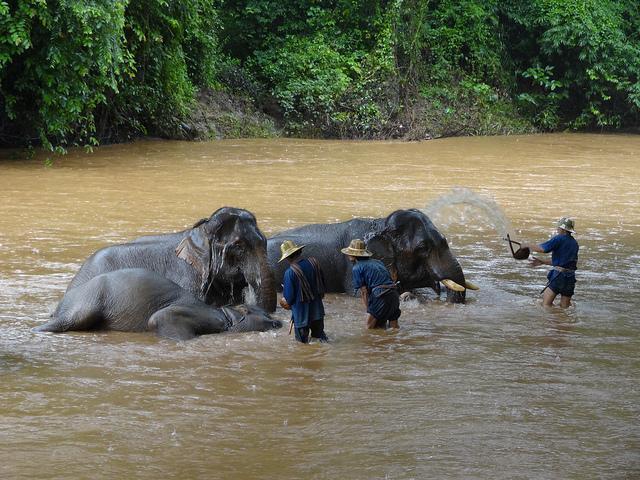How many trunks are on the elephants?
Give a very brief answer. 2. How many elephants are in the photo?
Give a very brief answer. 3. How many people are visible?
Give a very brief answer. 3. 